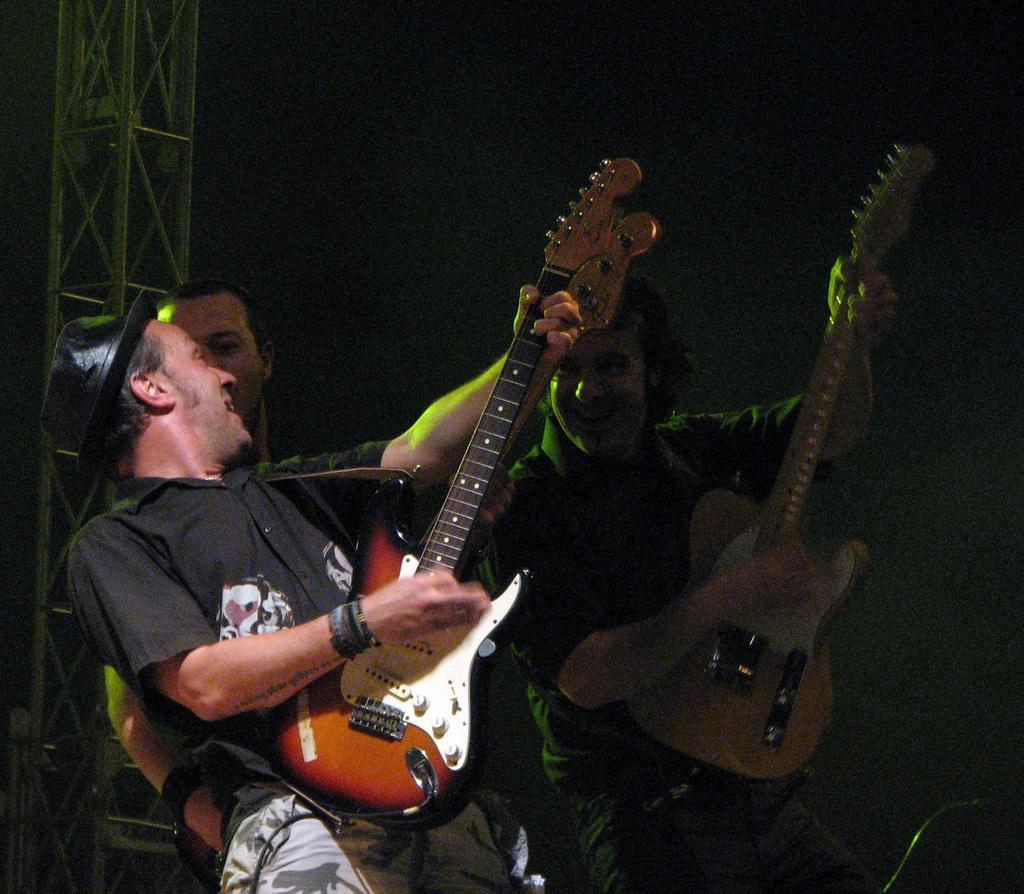Can you describe this image briefly? This picture is consists of a people those who are playing the guitars at the center of the image and there are spotlights above the area of the image. 